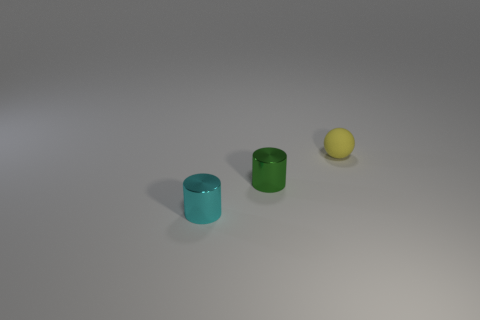What number of other objects are there of the same color as the matte object?
Provide a succinct answer. 0. Is there anything else that is the same shape as the yellow rubber object?
Ensure brevity in your answer.  No. Are there any small green cylinders made of the same material as the cyan cylinder?
Offer a very short reply. Yes. The cyan thing that is the same shape as the small green thing is what size?
Your answer should be very brief. Small. Is the number of yellow rubber objects left of the matte object the same as the number of yellow matte things?
Provide a succinct answer. No. There is a metallic object to the right of the cyan metallic thing; is its shape the same as the small cyan metal object?
Your answer should be very brief. Yes. The cyan metallic thing has what shape?
Ensure brevity in your answer.  Cylinder. What is the material of the tiny cylinder that is on the left side of the cylinder that is on the right side of the small metal object in front of the green shiny thing?
Your answer should be very brief. Metal. What number of objects are either large cyan matte blocks or yellow matte spheres?
Your response must be concise. 1. Are the tiny cylinder that is on the left side of the small green shiny object and the sphere made of the same material?
Your answer should be compact. No. 